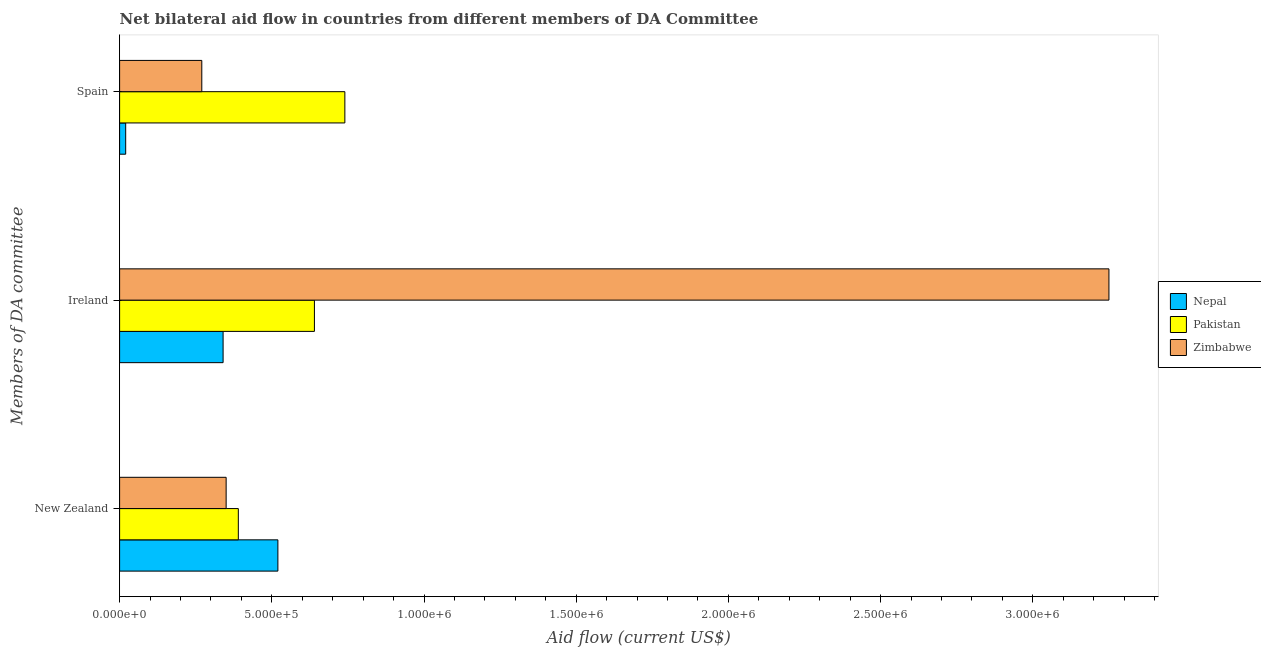How many different coloured bars are there?
Offer a very short reply. 3. How many groups of bars are there?
Make the answer very short. 3. Are the number of bars on each tick of the Y-axis equal?
Your answer should be compact. Yes. How many bars are there on the 1st tick from the bottom?
Your answer should be compact. 3. What is the label of the 2nd group of bars from the top?
Offer a terse response. Ireland. What is the amount of aid provided by new zealand in Nepal?
Your answer should be compact. 5.20e+05. Across all countries, what is the maximum amount of aid provided by ireland?
Offer a terse response. 3.25e+06. Across all countries, what is the minimum amount of aid provided by spain?
Offer a terse response. 2.00e+04. In which country was the amount of aid provided by ireland maximum?
Give a very brief answer. Zimbabwe. In which country was the amount of aid provided by new zealand minimum?
Offer a terse response. Zimbabwe. What is the total amount of aid provided by spain in the graph?
Provide a short and direct response. 1.03e+06. What is the difference between the amount of aid provided by spain in Pakistan and that in Zimbabwe?
Offer a terse response. 4.70e+05. What is the difference between the amount of aid provided by ireland in Pakistan and the amount of aid provided by new zealand in Zimbabwe?
Keep it short and to the point. 2.90e+05. What is the average amount of aid provided by spain per country?
Keep it short and to the point. 3.43e+05. What is the difference between the amount of aid provided by ireland and amount of aid provided by new zealand in Pakistan?
Make the answer very short. 2.50e+05. What is the ratio of the amount of aid provided by ireland in Zimbabwe to that in Nepal?
Give a very brief answer. 9.56. Is the difference between the amount of aid provided by new zealand in Nepal and Pakistan greater than the difference between the amount of aid provided by ireland in Nepal and Pakistan?
Keep it short and to the point. Yes. What is the difference between the highest and the second highest amount of aid provided by ireland?
Provide a succinct answer. 2.61e+06. What is the difference between the highest and the lowest amount of aid provided by new zealand?
Give a very brief answer. 1.70e+05. What does the 1st bar from the top in New Zealand represents?
Make the answer very short. Zimbabwe. What does the 3rd bar from the bottom in Ireland represents?
Your answer should be very brief. Zimbabwe. Is it the case that in every country, the sum of the amount of aid provided by new zealand and amount of aid provided by ireland is greater than the amount of aid provided by spain?
Your answer should be compact. Yes. How many bars are there?
Ensure brevity in your answer.  9. Are all the bars in the graph horizontal?
Provide a succinct answer. Yes. How many countries are there in the graph?
Give a very brief answer. 3. What is the difference between two consecutive major ticks on the X-axis?
Provide a succinct answer. 5.00e+05. Are the values on the major ticks of X-axis written in scientific E-notation?
Your answer should be compact. Yes. Does the graph contain grids?
Your answer should be compact. No. How many legend labels are there?
Your answer should be compact. 3. How are the legend labels stacked?
Your answer should be very brief. Vertical. What is the title of the graph?
Give a very brief answer. Net bilateral aid flow in countries from different members of DA Committee. Does "Aruba" appear as one of the legend labels in the graph?
Make the answer very short. No. What is the label or title of the X-axis?
Provide a short and direct response. Aid flow (current US$). What is the label or title of the Y-axis?
Provide a succinct answer. Members of DA committee. What is the Aid flow (current US$) of Nepal in New Zealand?
Your response must be concise. 5.20e+05. What is the Aid flow (current US$) in Pakistan in New Zealand?
Give a very brief answer. 3.90e+05. What is the Aid flow (current US$) of Nepal in Ireland?
Keep it short and to the point. 3.40e+05. What is the Aid flow (current US$) of Pakistan in Ireland?
Provide a succinct answer. 6.40e+05. What is the Aid flow (current US$) of Zimbabwe in Ireland?
Give a very brief answer. 3.25e+06. What is the Aid flow (current US$) in Pakistan in Spain?
Ensure brevity in your answer.  7.40e+05. What is the Aid flow (current US$) in Zimbabwe in Spain?
Keep it short and to the point. 2.70e+05. Across all Members of DA committee, what is the maximum Aid flow (current US$) of Nepal?
Make the answer very short. 5.20e+05. Across all Members of DA committee, what is the maximum Aid flow (current US$) in Pakistan?
Offer a very short reply. 7.40e+05. Across all Members of DA committee, what is the maximum Aid flow (current US$) of Zimbabwe?
Offer a very short reply. 3.25e+06. What is the total Aid flow (current US$) of Nepal in the graph?
Your answer should be very brief. 8.80e+05. What is the total Aid flow (current US$) of Pakistan in the graph?
Provide a succinct answer. 1.77e+06. What is the total Aid flow (current US$) of Zimbabwe in the graph?
Make the answer very short. 3.87e+06. What is the difference between the Aid flow (current US$) of Pakistan in New Zealand and that in Ireland?
Your answer should be compact. -2.50e+05. What is the difference between the Aid flow (current US$) of Zimbabwe in New Zealand and that in Ireland?
Give a very brief answer. -2.90e+06. What is the difference between the Aid flow (current US$) in Nepal in New Zealand and that in Spain?
Give a very brief answer. 5.00e+05. What is the difference between the Aid flow (current US$) of Pakistan in New Zealand and that in Spain?
Offer a very short reply. -3.50e+05. What is the difference between the Aid flow (current US$) of Zimbabwe in New Zealand and that in Spain?
Keep it short and to the point. 8.00e+04. What is the difference between the Aid flow (current US$) of Nepal in Ireland and that in Spain?
Offer a very short reply. 3.20e+05. What is the difference between the Aid flow (current US$) in Zimbabwe in Ireland and that in Spain?
Your response must be concise. 2.98e+06. What is the difference between the Aid flow (current US$) in Nepal in New Zealand and the Aid flow (current US$) in Zimbabwe in Ireland?
Provide a succinct answer. -2.73e+06. What is the difference between the Aid flow (current US$) of Pakistan in New Zealand and the Aid flow (current US$) of Zimbabwe in Ireland?
Provide a short and direct response. -2.86e+06. What is the difference between the Aid flow (current US$) in Nepal in New Zealand and the Aid flow (current US$) in Pakistan in Spain?
Offer a terse response. -2.20e+05. What is the difference between the Aid flow (current US$) in Nepal in Ireland and the Aid flow (current US$) in Pakistan in Spain?
Your answer should be very brief. -4.00e+05. What is the difference between the Aid flow (current US$) in Nepal in Ireland and the Aid flow (current US$) in Zimbabwe in Spain?
Provide a short and direct response. 7.00e+04. What is the difference between the Aid flow (current US$) of Pakistan in Ireland and the Aid flow (current US$) of Zimbabwe in Spain?
Offer a terse response. 3.70e+05. What is the average Aid flow (current US$) of Nepal per Members of DA committee?
Your answer should be very brief. 2.93e+05. What is the average Aid flow (current US$) of Pakistan per Members of DA committee?
Offer a terse response. 5.90e+05. What is the average Aid flow (current US$) in Zimbabwe per Members of DA committee?
Ensure brevity in your answer.  1.29e+06. What is the difference between the Aid flow (current US$) in Nepal and Aid flow (current US$) in Pakistan in New Zealand?
Make the answer very short. 1.30e+05. What is the difference between the Aid flow (current US$) in Nepal and Aid flow (current US$) in Zimbabwe in New Zealand?
Ensure brevity in your answer.  1.70e+05. What is the difference between the Aid flow (current US$) of Nepal and Aid flow (current US$) of Zimbabwe in Ireland?
Your answer should be very brief. -2.91e+06. What is the difference between the Aid flow (current US$) in Pakistan and Aid flow (current US$) in Zimbabwe in Ireland?
Provide a short and direct response. -2.61e+06. What is the difference between the Aid flow (current US$) of Nepal and Aid flow (current US$) of Pakistan in Spain?
Offer a terse response. -7.20e+05. What is the difference between the Aid flow (current US$) of Nepal and Aid flow (current US$) of Zimbabwe in Spain?
Make the answer very short. -2.50e+05. What is the difference between the Aid flow (current US$) of Pakistan and Aid flow (current US$) of Zimbabwe in Spain?
Your answer should be compact. 4.70e+05. What is the ratio of the Aid flow (current US$) of Nepal in New Zealand to that in Ireland?
Your response must be concise. 1.53. What is the ratio of the Aid flow (current US$) of Pakistan in New Zealand to that in Ireland?
Make the answer very short. 0.61. What is the ratio of the Aid flow (current US$) in Zimbabwe in New Zealand to that in Ireland?
Make the answer very short. 0.11. What is the ratio of the Aid flow (current US$) of Pakistan in New Zealand to that in Spain?
Offer a very short reply. 0.53. What is the ratio of the Aid flow (current US$) of Zimbabwe in New Zealand to that in Spain?
Ensure brevity in your answer.  1.3. What is the ratio of the Aid flow (current US$) in Pakistan in Ireland to that in Spain?
Offer a very short reply. 0.86. What is the ratio of the Aid flow (current US$) in Zimbabwe in Ireland to that in Spain?
Your answer should be compact. 12.04. What is the difference between the highest and the second highest Aid flow (current US$) of Nepal?
Your answer should be compact. 1.80e+05. What is the difference between the highest and the second highest Aid flow (current US$) of Zimbabwe?
Your answer should be compact. 2.90e+06. What is the difference between the highest and the lowest Aid flow (current US$) in Pakistan?
Your response must be concise. 3.50e+05. What is the difference between the highest and the lowest Aid flow (current US$) of Zimbabwe?
Your answer should be very brief. 2.98e+06. 